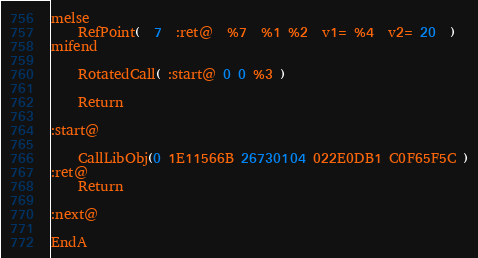Convert code to text. <code><loc_0><loc_0><loc_500><loc_500><_Scheme_>melse
	RefPoint(  7  :ret@  %7  %1 %2  v1= %4  v2= 20  )
mifend

	RotatedCall( :start@ 0 0 %3 )

	Return

:start@

	CallLibObj(0 1E11566B 26730104 022E0DB1 C0F65F5C )
:ret@
	Return

:next@

EndA</code> 